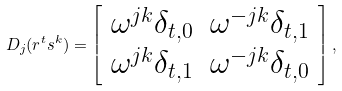Convert formula to latex. <formula><loc_0><loc_0><loc_500><loc_500>D _ { j } ( r ^ { t } s ^ { k } ) = \left [ \begin{array} { c c } \omega ^ { j k } \delta _ { t , 0 } & \omega ^ { - j k } \delta _ { t , 1 } \\ \omega ^ { j k } \delta _ { t , 1 } & \omega ^ { - j k } \delta _ { t , 0 } \end{array} \right ] ,</formula> 